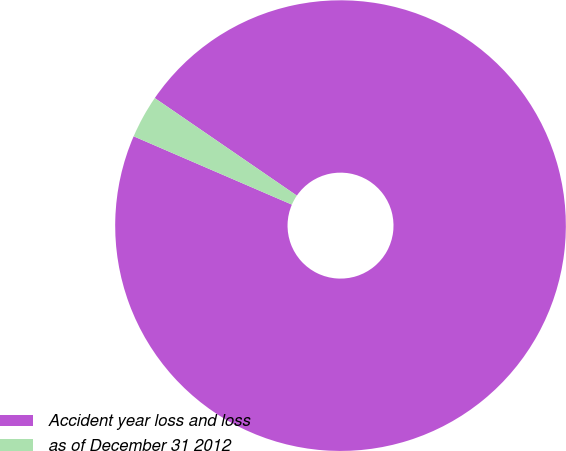<chart> <loc_0><loc_0><loc_500><loc_500><pie_chart><fcel>Accident year loss and loss<fcel>as of December 31 2012<nl><fcel>96.91%<fcel>3.09%<nl></chart> 